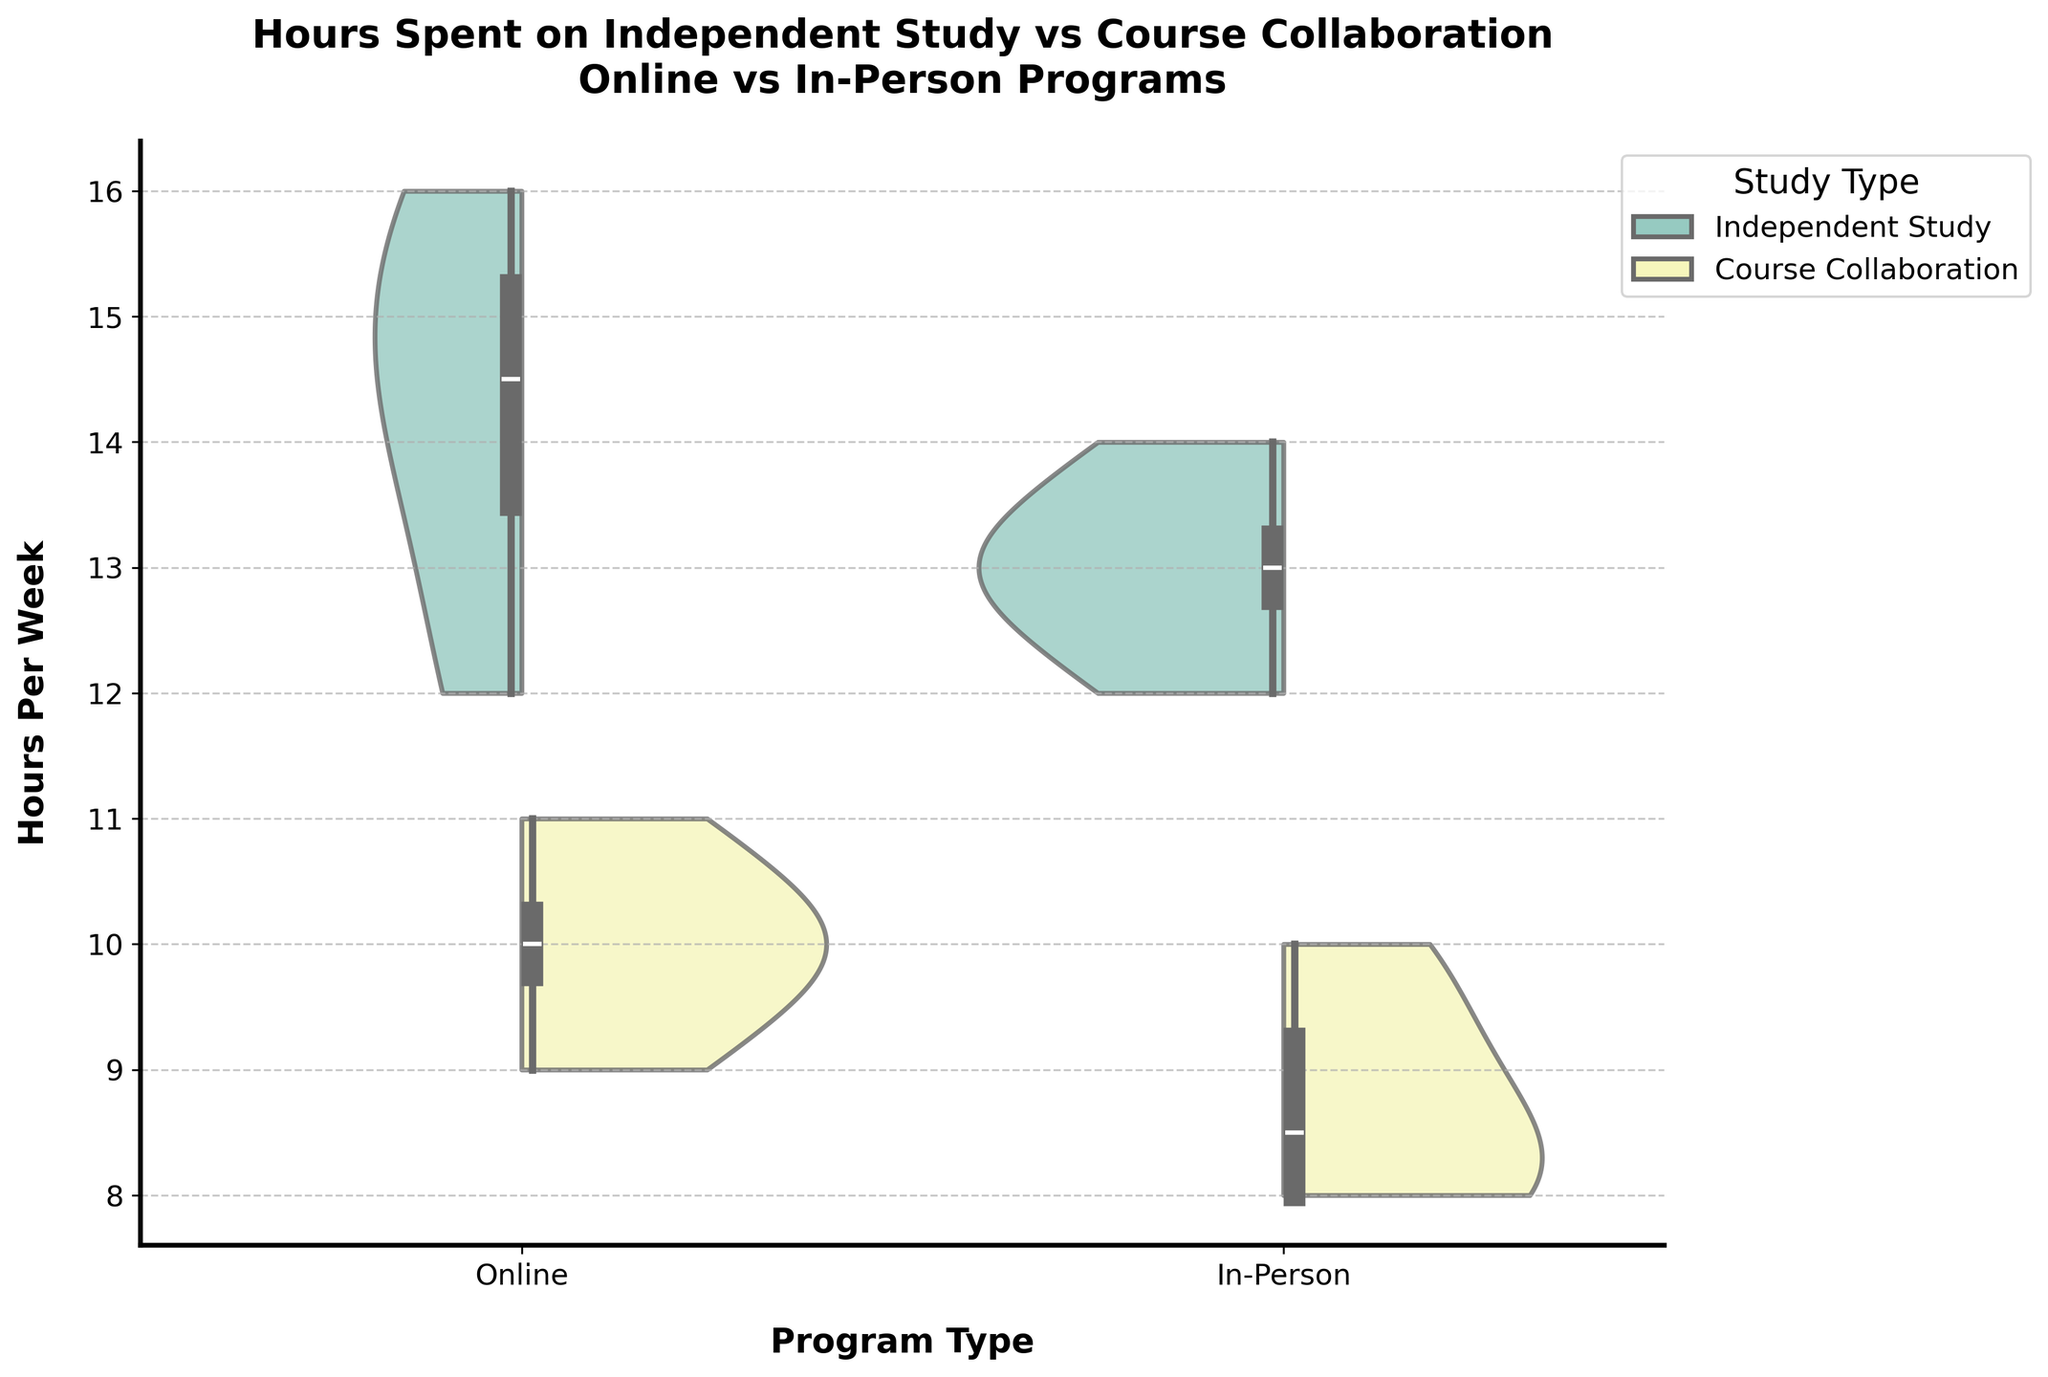What's the title of the figure? The title is the main text at the top of the figure that summarizes the content. In this figure, it reads: "Hours Spent on Independent Study vs Course Collaboration Online vs In-Person Programs"
Answer: Hours Spent on Independent Study vs Course Collaboration Online vs In-Person Programs What are the two study types compared in the figure? The study types are represented by different colors within each violin plot. According to the legend, the two study types are "Independent Study" and "Course Collaboration."
Answer: Independent Study and Course Collaboration Which program type appears to have a greater range of hours spent on Independent Study? By examining the width of the violins for Independent Study, the Online program type shows a broader spread from around 12 to 16 hours per week compared to the In-Person program type, which ranges approximately from 12 to 14 hours.
Answer: Online What is the median number of hours spent on Course Collaboration in the Online program? From the box plot inside the Online Course Collaboration violin, the median is the middle line of the box. This line is at the 10-hour mark.
Answer: 10 hours Which study type shows a higher median number of hours in the In-Person program? The median is represented by the middle line of the box plots within the violins. Comparing the median lines, Independent Study has a higher median than Course Collaboration in the In-Person program.
Answer: Independent Study What's the difference in the median hours spent on Independent Study between Online and In-Person programs? The median for Online Independent Study is around 14.5 hours, and the median for In-Person Independent Study is around 13 hours. The difference is 14.5 - 13 = 1.5 hours.
Answer: 1.5 hours Do any students in the Online program spend more than 16 hours per week on Independent Study? By looking at the maximum value (top most point of the violin) of the Online Independent Study violin plot, no student spends more than 16 hours on Independent Study.
Answer: No How do the distributions of hours spent on Course Collaboration compare between Online and In-Person programs? The width and spread of the violin plots for Course Collaboration show that the Online program has a wider range, indicating more variability. In contrast, the In-Person program's distribution is narrower and more centered around 8-10 hours.
Answer: Online has more variability, In-Person is more centered around 8-10 hours What's the interquartile range (IQR) for hours spent on Independent Study in the Online program? The IQR is the difference between the first quartile (bottom of the box) and the third quartile (top of the box). For the Online Independent Study, the first quartile is around 13 hours and the third quartile is around 15 hours. The IQR is 15 - 13 = 2 hours.
Answer: 2 hours 